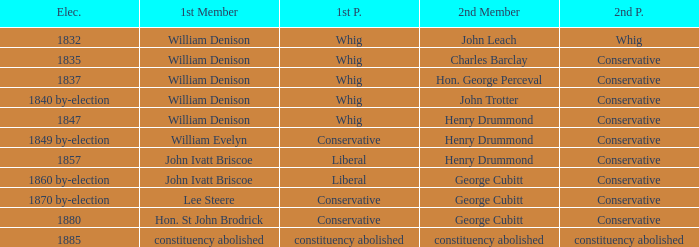Which party with an 1835 election has 1st member William Denison? Conservative. 